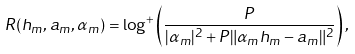Convert formula to latex. <formula><loc_0><loc_0><loc_500><loc_500>R ( h _ { m } , a _ { m } , \alpha _ { m } ) = \log ^ { + } \left ( \frac { P } { | \alpha _ { m } | ^ { 2 } + P \| \alpha _ { m } h _ { m } - a _ { m } \| ^ { 2 } } \right ) ,</formula> 